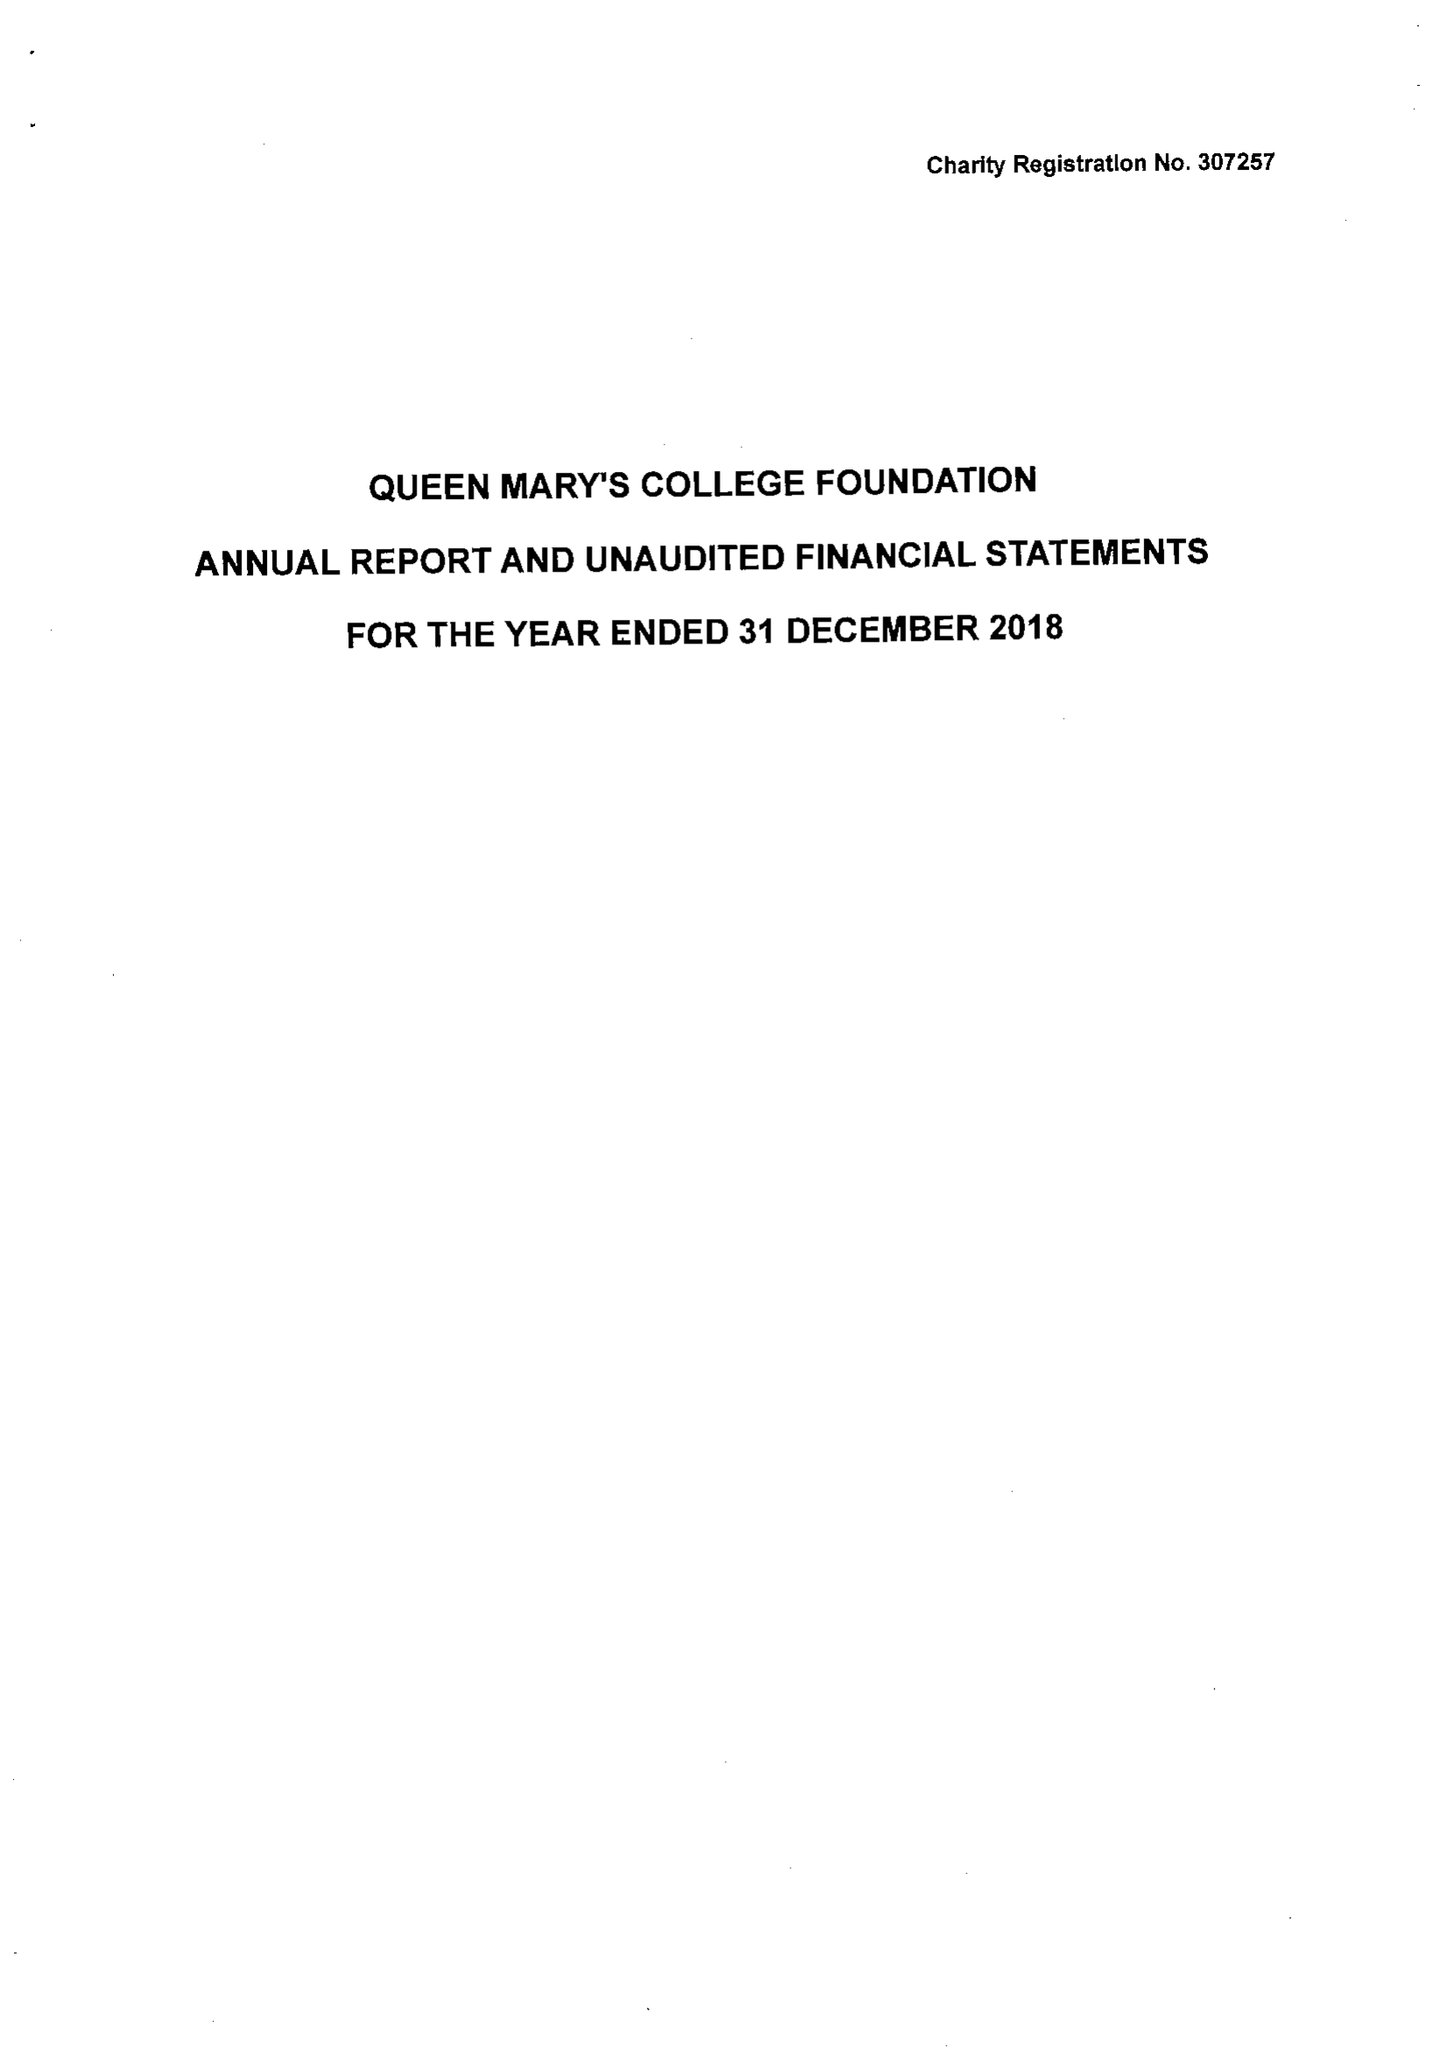What is the value for the address__postcode?
Answer the question using a single word or phrase. RG21 3HF 